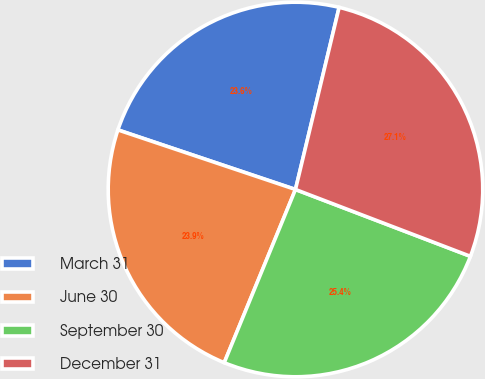<chart> <loc_0><loc_0><loc_500><loc_500><pie_chart><fcel>March 31<fcel>June 30<fcel>September 30<fcel>December 31<nl><fcel>23.59%<fcel>23.94%<fcel>25.4%<fcel>27.06%<nl></chart> 